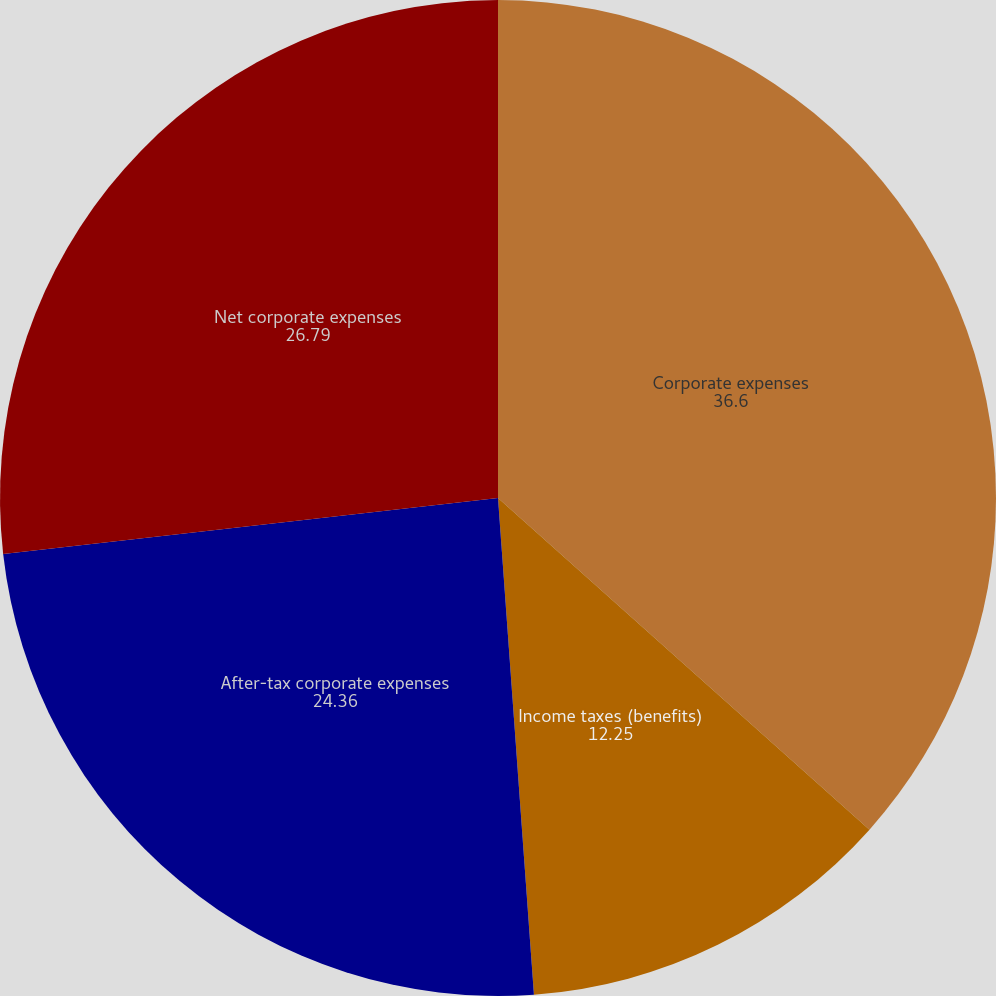<chart> <loc_0><loc_0><loc_500><loc_500><pie_chart><fcel>Corporate expenses<fcel>Income taxes (benefits)<fcel>After-tax corporate expenses<fcel>Net corporate expenses<nl><fcel>36.6%<fcel>12.25%<fcel>24.36%<fcel>26.79%<nl></chart> 